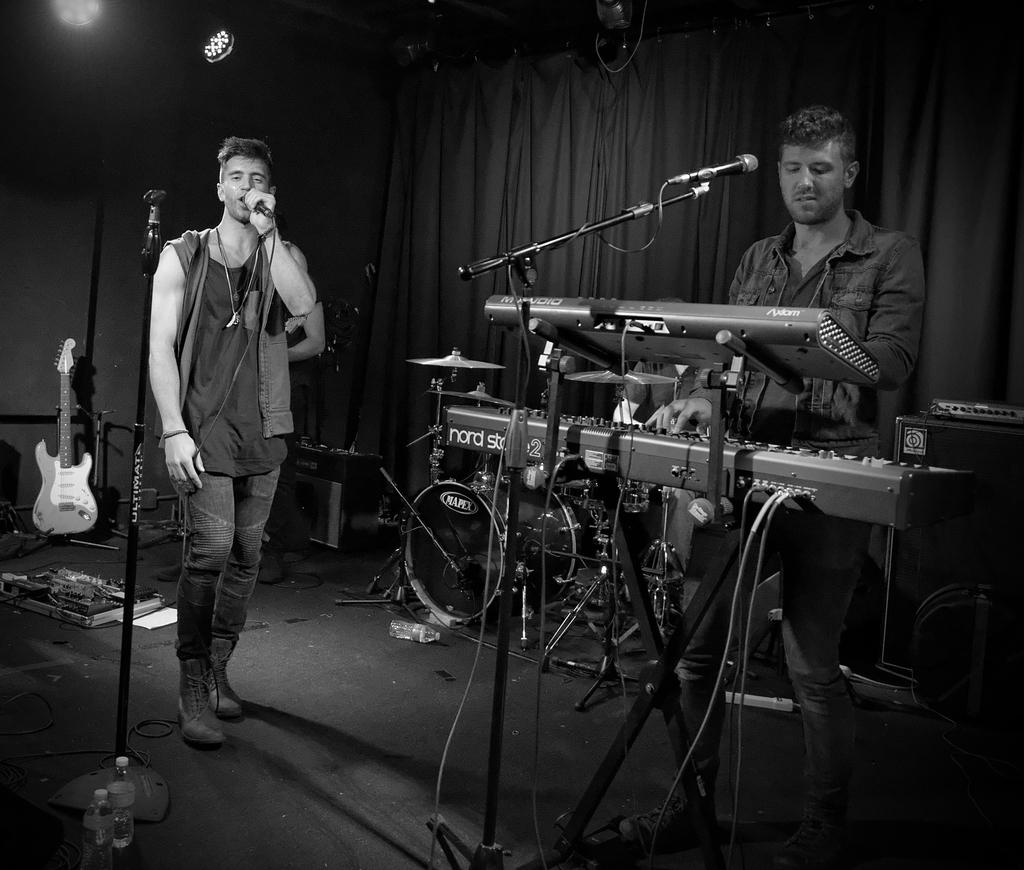What is the man in the image doing? The man in the image is singing. How is the man amplifying his voice in the image? The man is using a microphone. What other person is present in the image and what are they doing? There is a man playing a musical instrument in the image. What can be seen in the background of the image? There is a curtain visible in the image. Can you see the tail of the hen in the image? There is no hen or tail present in the image. 